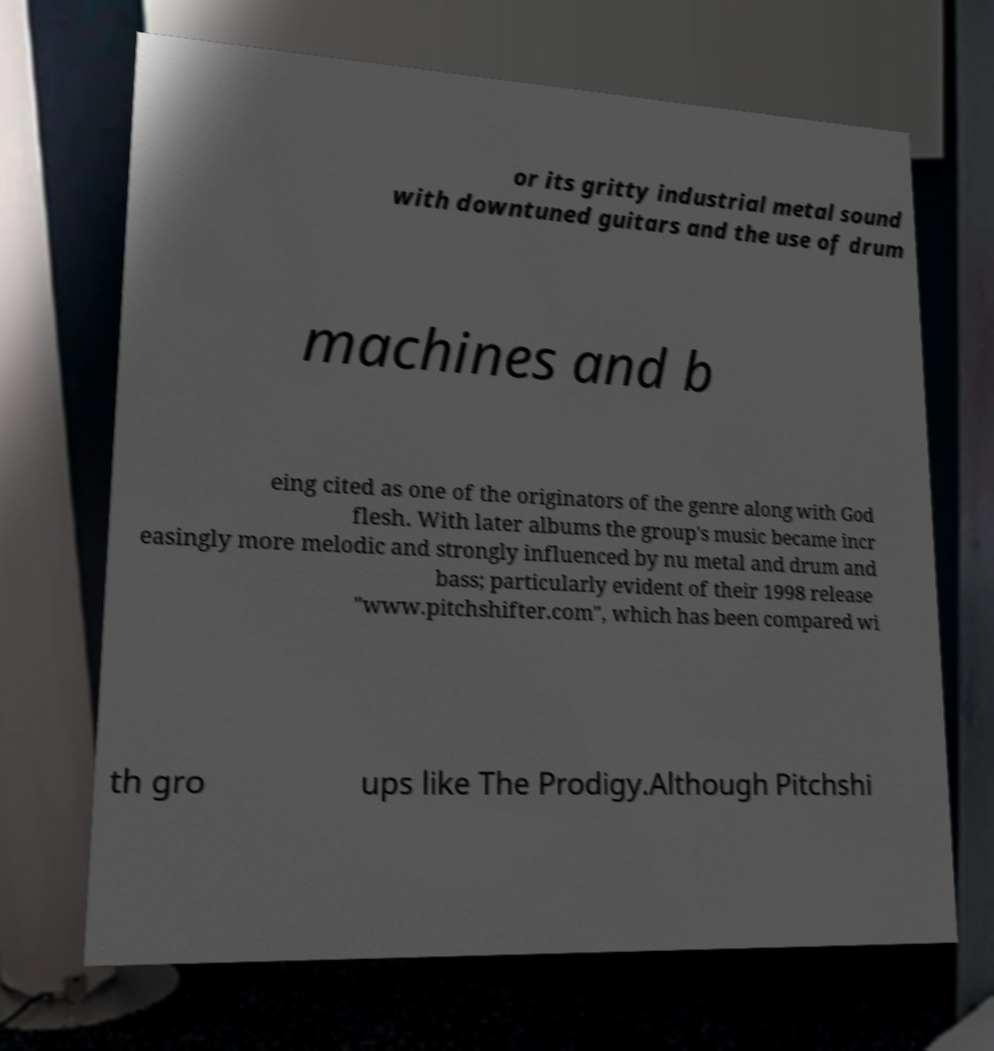I need the written content from this picture converted into text. Can you do that? or its gritty industrial metal sound with downtuned guitars and the use of drum machines and b eing cited as one of the originators of the genre along with God flesh. With later albums the group's music became incr easingly more melodic and strongly influenced by nu metal and drum and bass; particularly evident of their 1998 release "www.pitchshifter.com", which has been compared wi th gro ups like The Prodigy.Although Pitchshi 